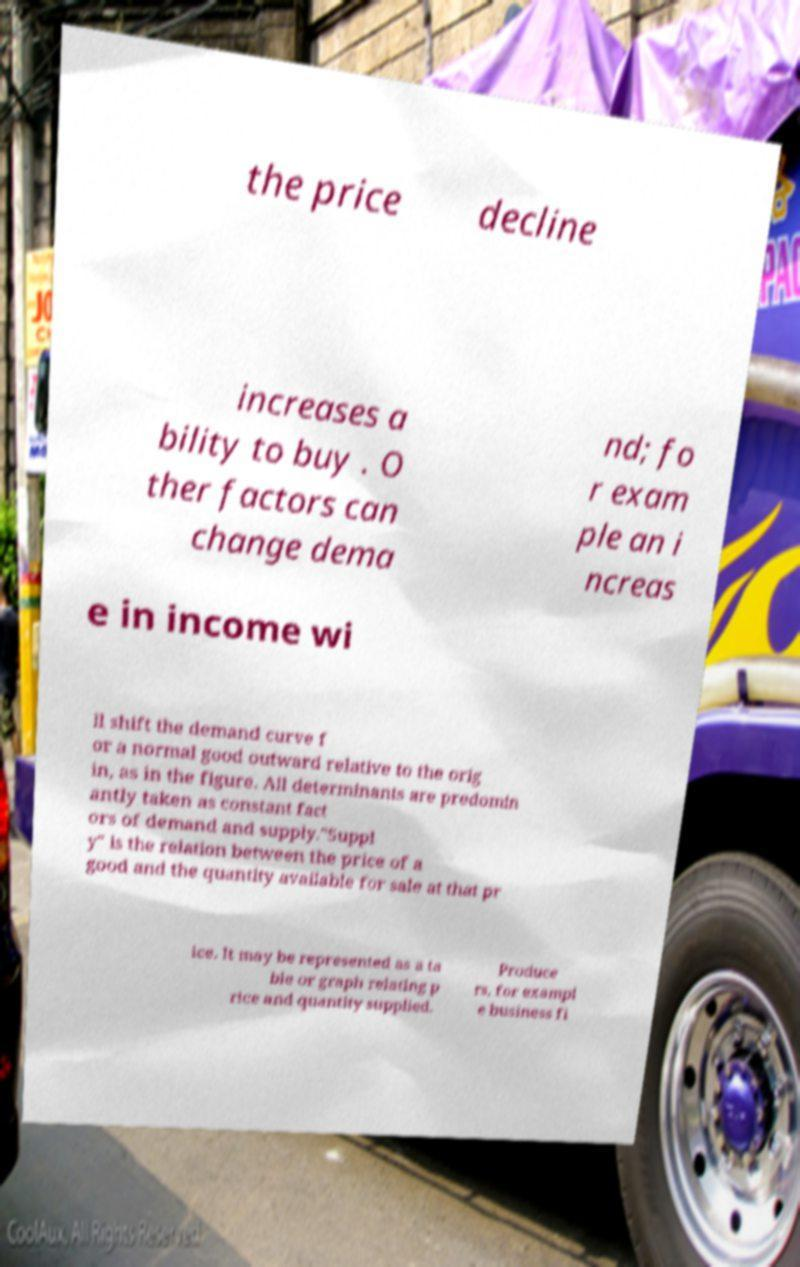Can you read and provide the text displayed in the image?This photo seems to have some interesting text. Can you extract and type it out for me? the price decline increases a bility to buy . O ther factors can change dema nd; fo r exam ple an i ncreas e in income wi ll shift the demand curve f or a normal good outward relative to the orig in, as in the figure. All determinants are predomin antly taken as constant fact ors of demand and supply."Suppl y" is the relation between the price of a good and the quantity available for sale at that pr ice. It may be represented as a ta ble or graph relating p rice and quantity supplied. Produce rs, for exampl e business fi 